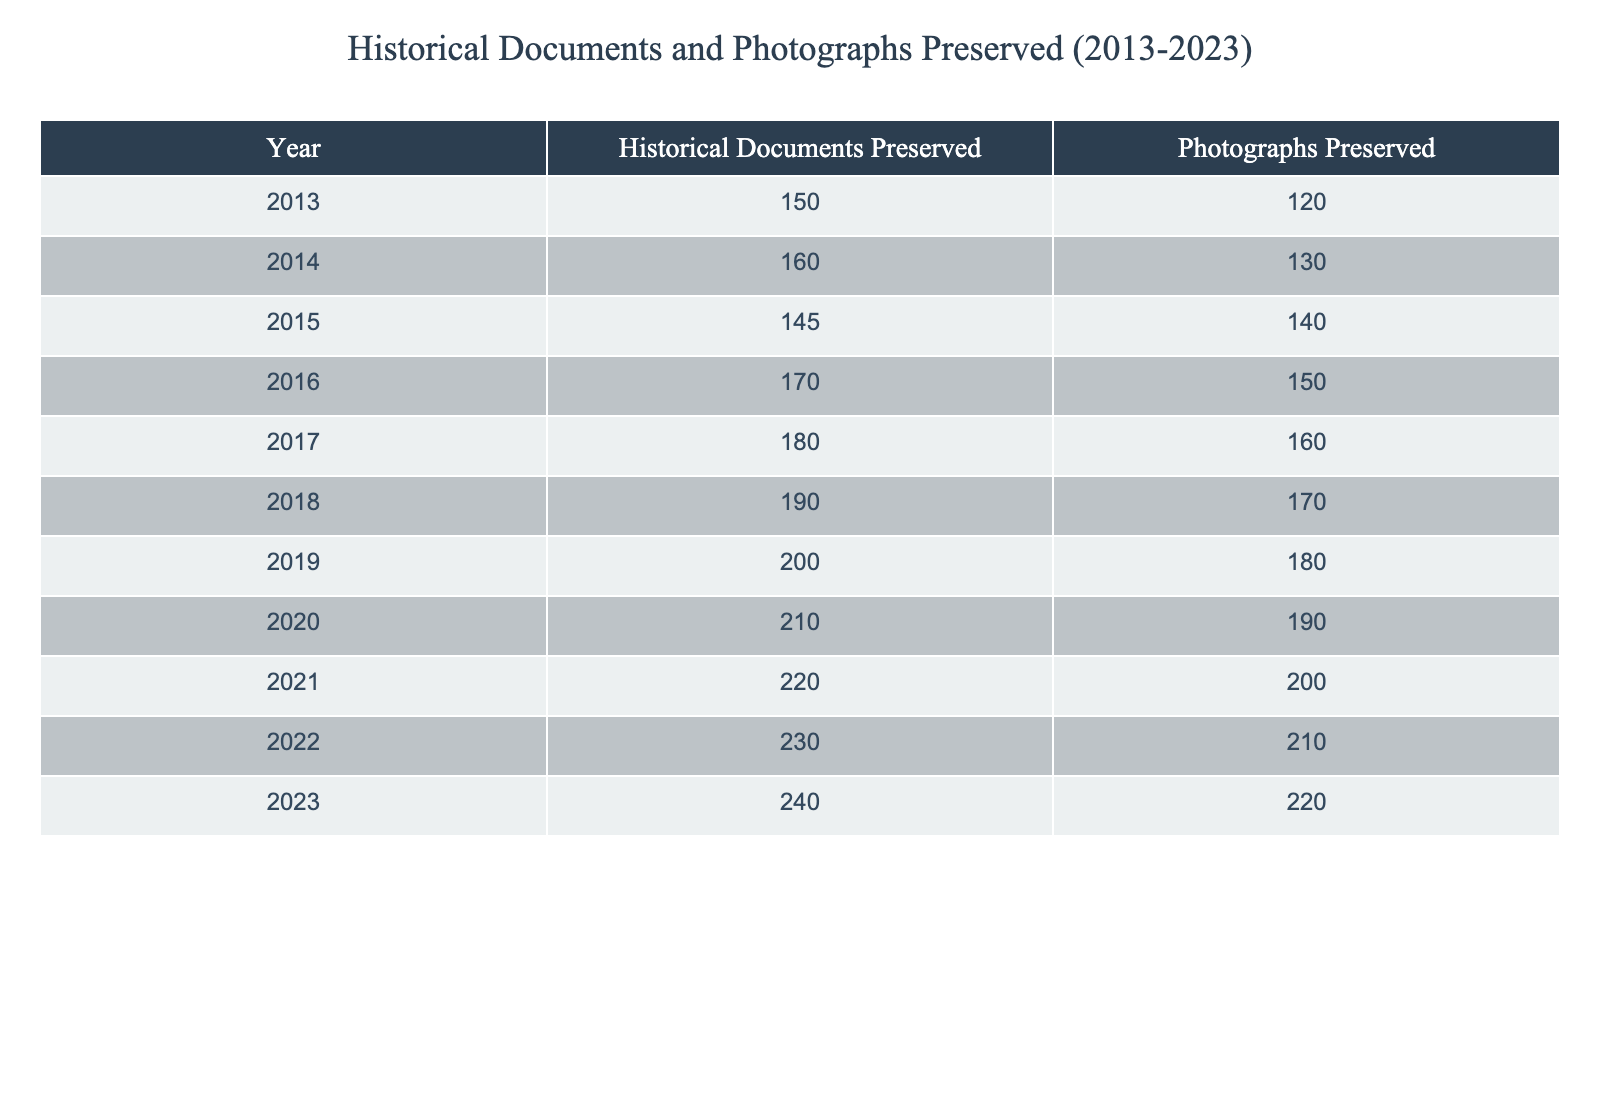What was the total number of historical documents preserved from 2013 to 2023? To find the total number of historical documents preserved, we add the values from each year: 150 + 160 + 145 + 170 + 180 + 190 + 200 + 210 + 220 + 230 + 240 = 2,155.
Answer: 2155 What year saw the highest number of photographs preserved? Looking through the photographs preserved each year, we see the highest value is 220 in the year 2023.
Answer: 2023 What is the average number of historical documents preserved annually over the last decade? We first calculate the total number of historical documents preserved, which is 2,155. Then we divide by the number of years, which is 11 (from 2013 to 2023). Thus, 2,155 / 11 = 195.91.
Answer: 195.91 Did more photographs than historical documents get preserved in each year from 2013 to 2023? We compare the values for photographs and historical documents each year. We see that from 2013 to 2023, photographs were always fewer than historical documents until 2023, where they are equal. Therefore, the answer is no.
Answer: No What is the increase in the number of historical documents preserved from 2013 to 2023? We take the number of historical documents preserved in 2023, which is 240, and subtract the number preserved in 2013, which is 150. So, 240 - 150 = 90.
Answer: 90 What was the trend in the number of photographs preserved from 2013 to 2023? By examining the numbers annually, we see a consistent increase each year, from 120 in 2013 to 220 in 2023, indicating a positive trend over the decade.
Answer: Positive trend What is the combined total of both historical documents and photographs preserved in 2020? In 2020, the number of historical documents preserved was 210 and photographs preserved was 190. Adding these together gives 210 + 190 = 400.
Answer: 400 In which year was the difference between historical documents and photographs preserved the largest? We calculate the yearly differences: in 2013, it’s 30; in 2014, it’s 30; in 2015, it’s 5; in 2016, it’s 20; in 2017, it’s 20; in 2018, it’s 20; in 2019, it’s 20; in 2020, it’s 20; in 2021, it’s 20; in 2022, it’s 20; in 2023, it’s 20. The largest difference is 30 in both 2013 and 2014.
Answer: 2013 and 2014 